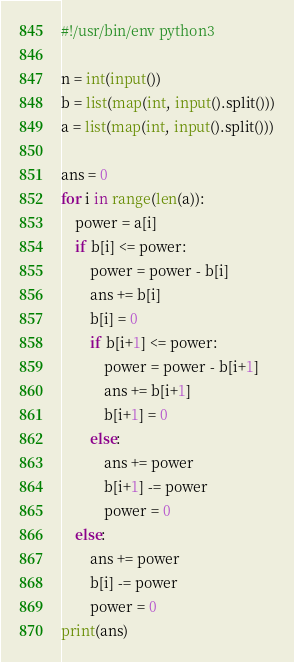<code> <loc_0><loc_0><loc_500><loc_500><_Python_>#!/usr/bin/env python3

n = int(input())
b = list(map(int, input().split()))
a = list(map(int, input().split()))

ans = 0
for i in range(len(a)):
    power = a[i]
    if b[i] <= power:
        power = power - b[i]
        ans += b[i]
        b[i] = 0
        if b[i+1] <= power:
            power = power - b[i+1]
            ans += b[i+1]
            b[i+1] = 0
        else:
            ans += power
            b[i+1] -= power
            power = 0
    else:
        ans += power
        b[i] -= power
        power = 0
print(ans)
</code> 